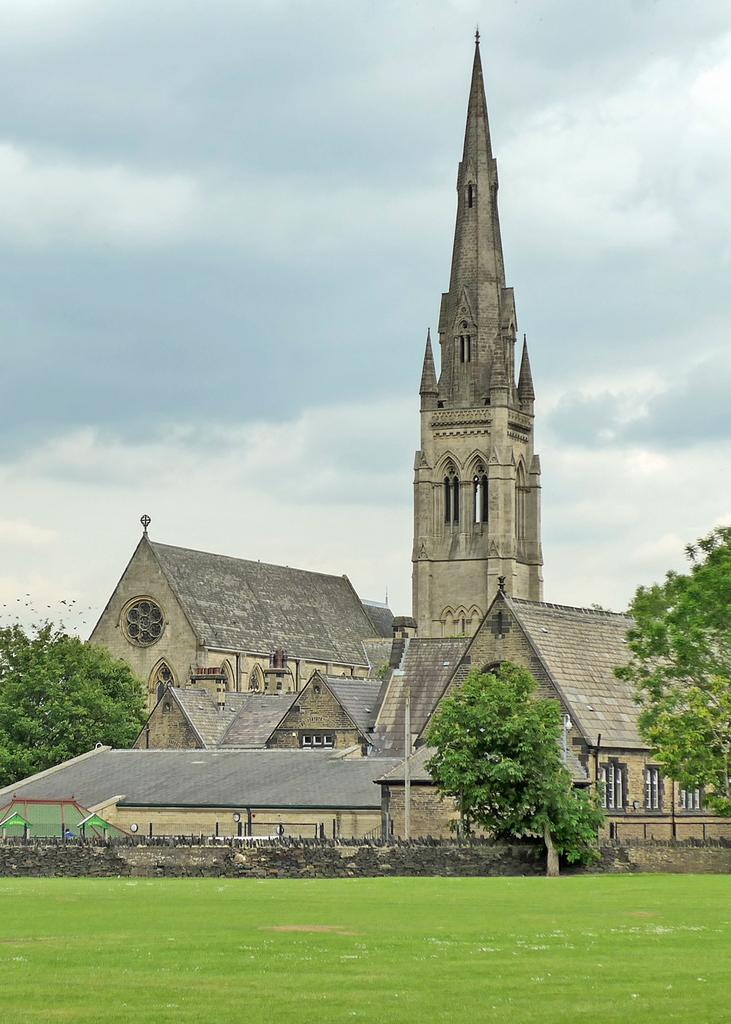What type of structures can be seen in the image? There are buildings and a tower in the image. Where is the tower located in relation to the buildings? The tower is in the middle of the image. What type of vegetation is present beside the buildings and tower? There are trees beside the buildings and tower. What is the ground covered with in the image? The ground appears to be covered in greenery. What type of quilt is being used for the operation in the image? There is no operation or quilt present in the image. 